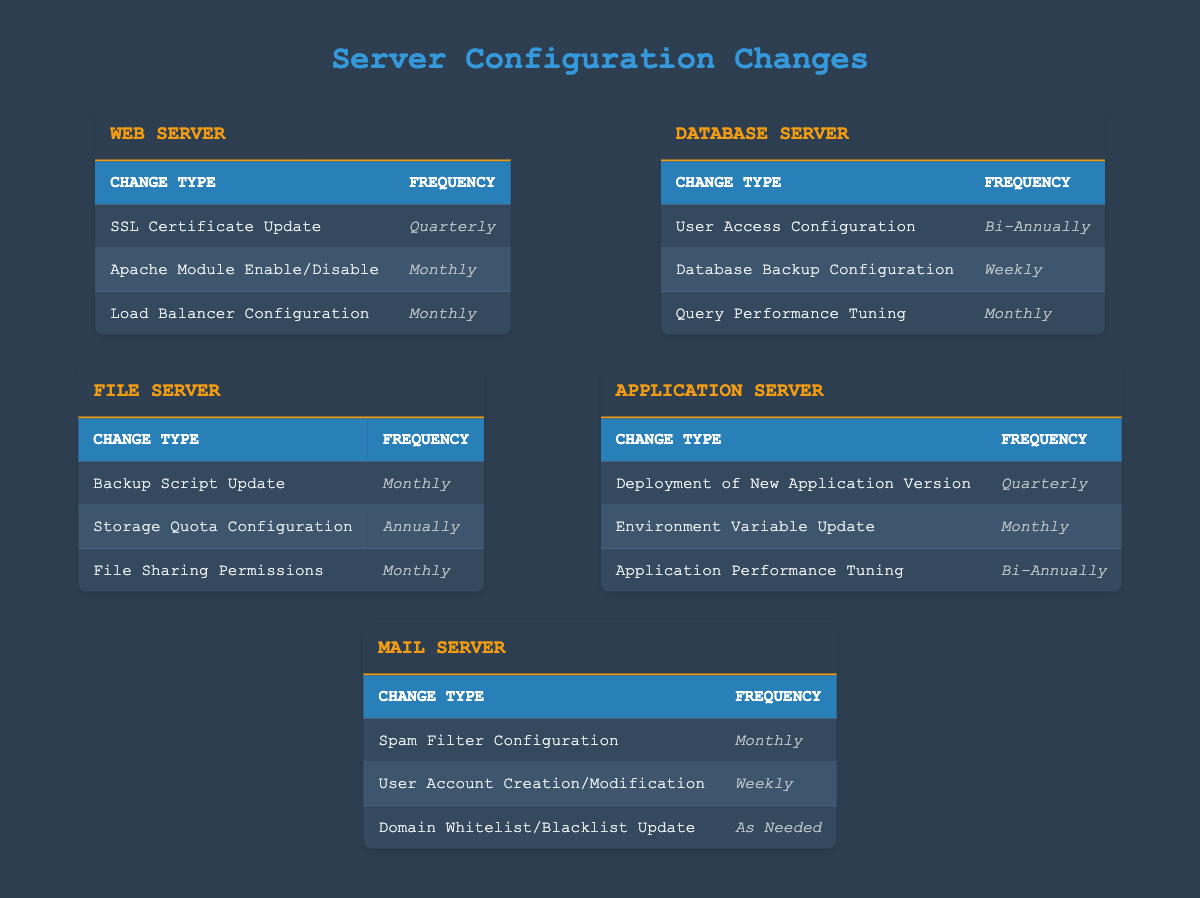What is the frequency of SSL Certificate Updates for Web Servers? The table specifies that SSL Certificate Updates for Web Servers occur quarterly. Therefore, the answer is directly taken from the corresponding row in the 'Web Server' section.
Answer: Quarterly How often do Database Servers perform Database Backup Configuration? According to the 'Database Server' section, Database Backup Configuration happens weekly. This can be found in the third row under the Database Server table.
Answer: Weekly Is the User Access Configuration for Database Servers done annually? Looking at the 'Database Server' section, User Access Configuration is reported to occur bi-annually, not annually. This establishes the answer as false.
Answer: No How many configuration changes for the File Server are performed monthly? From the 'File Server' section, there are three changes: Backup Script Update, File Sharing Permissions, and Load Balancer Configuration, performed monthly. Summing them gives us a total of three.
Answer: 3 What is the average frequency of changes for the Application Server? To find the average frequency, each frequency needs to be quantified: Quarterly (4), Monthly (1), and Bi-Annually (2). The sum total of frequencies is (4 + 1 + 2 = 7) and there are 3 changes. Therefore, the average frequency is 7/3 = approximately 2.33.
Answer: 2.33 Do Mail Servers update their Spam Filter Configuration more frequently than their User Account Creation/Modification? The table indicates that Spam Filter Configuration occurs monthly, while User Account Creation/Modification occurs weekly. Since monthly is a higher frequency than weekly, we can conclude the statement is false.
Answer: No What are the unique configurations for the Web Server? The unique configurations listed under the 'Web Server' section are: SSL Certificate Update, Apache Module Enable/Disable, and Load Balancer Configuration. These are all distinct and can be directly observed in the table.
Answer: 3 unique configurations How many server types perform configuration changes that are bi-annually? In the table, only the Application Server and Database Server have entries marked as bi-annually. Therefore, the total is 2.
Answer: 2 Are there any changes for the Mail Server that are performed as needed? The table indicates that the Domain Whitelist/Blacklist Update for the Mail Server is changed "As Needed" which directly answers this question affirmatively.
Answer: Yes 